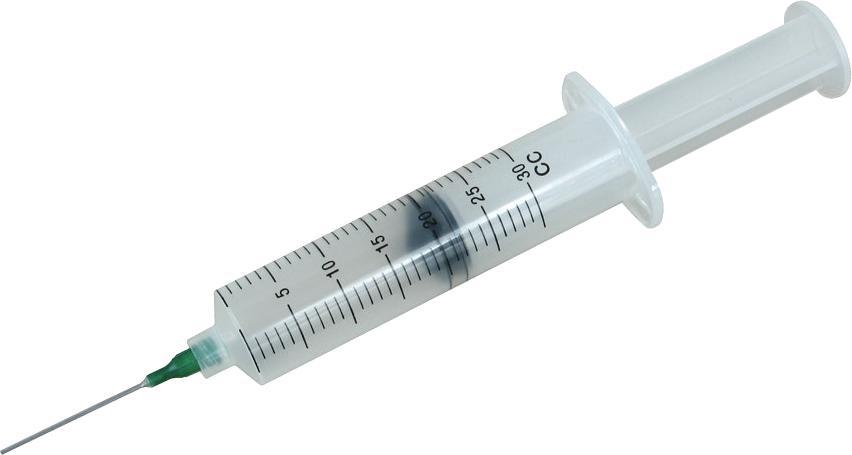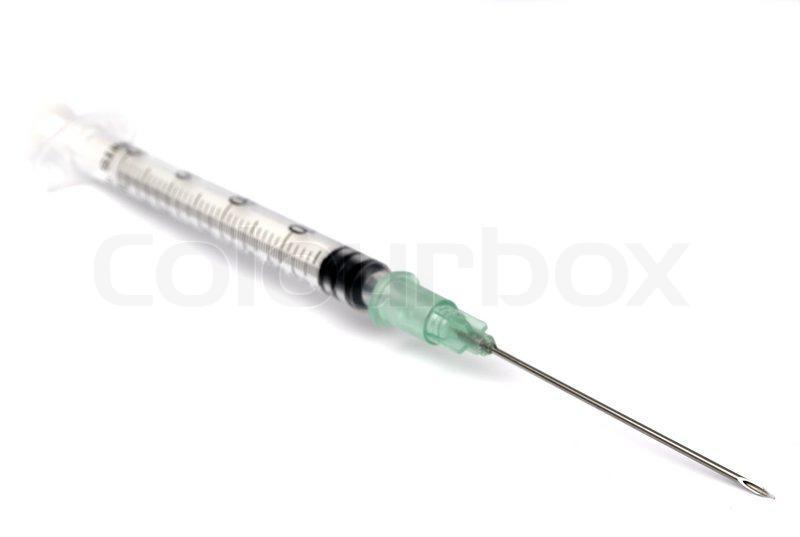The first image is the image on the left, the second image is the image on the right. Given the left and right images, does the statement "Each image shows only a single syringe." hold true? Answer yes or no. Yes. The first image is the image on the left, the second image is the image on the right. For the images shown, is this caption "Each image shows exactly one syringe, displayed at an angle." true? Answer yes or no. Yes. 